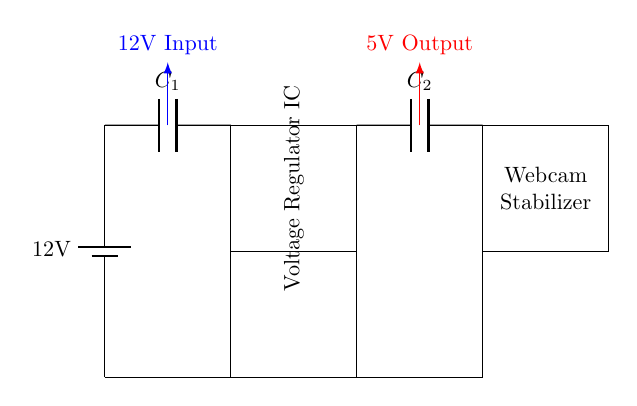What is the input voltage of this circuit? The input voltage is indicated at the source in the circuit diagram and is labeled as 12V. It is the voltage supplied by the battery.
Answer: 12V What is the output voltage of this circuit? The output voltage is shown in the circuit diagram as 5V, which is the voltage that the voltage regulator outputs to the load (webcam stabilizer).
Answer: 5V What components are used in this circuit? The circuit includes a battery, two capacitors (C1 and C2), and a voltage regulator IC. These components are essential for the functioning of the circuit.
Answer: Battery, capacitors, voltage regulator IC Why is a voltage regulator needed in this circuit? A voltage regulator is necessary to maintain a consistent 5V output voltage regardless of variations in input voltage or load conditions. This ensures proper operation of the webcam stabilizer.
Answer: To maintain a consistent 5V output Which component is responsible for smoothing the output voltage? The component responsible for smoothing the output voltage in the circuit is C2, the output capacitor. It helps to reduce voltage fluctuations and provide a smooth power supply to the load.
Answer: C2 What is the function of C1 in this circuit? C1 acts as an input capacitor which helps filter the supply voltage from the battery and reduces voltage spikes before it reaches the voltage regulator, ensuring stable operation.
Answer: To filter and stabilize input voltage 